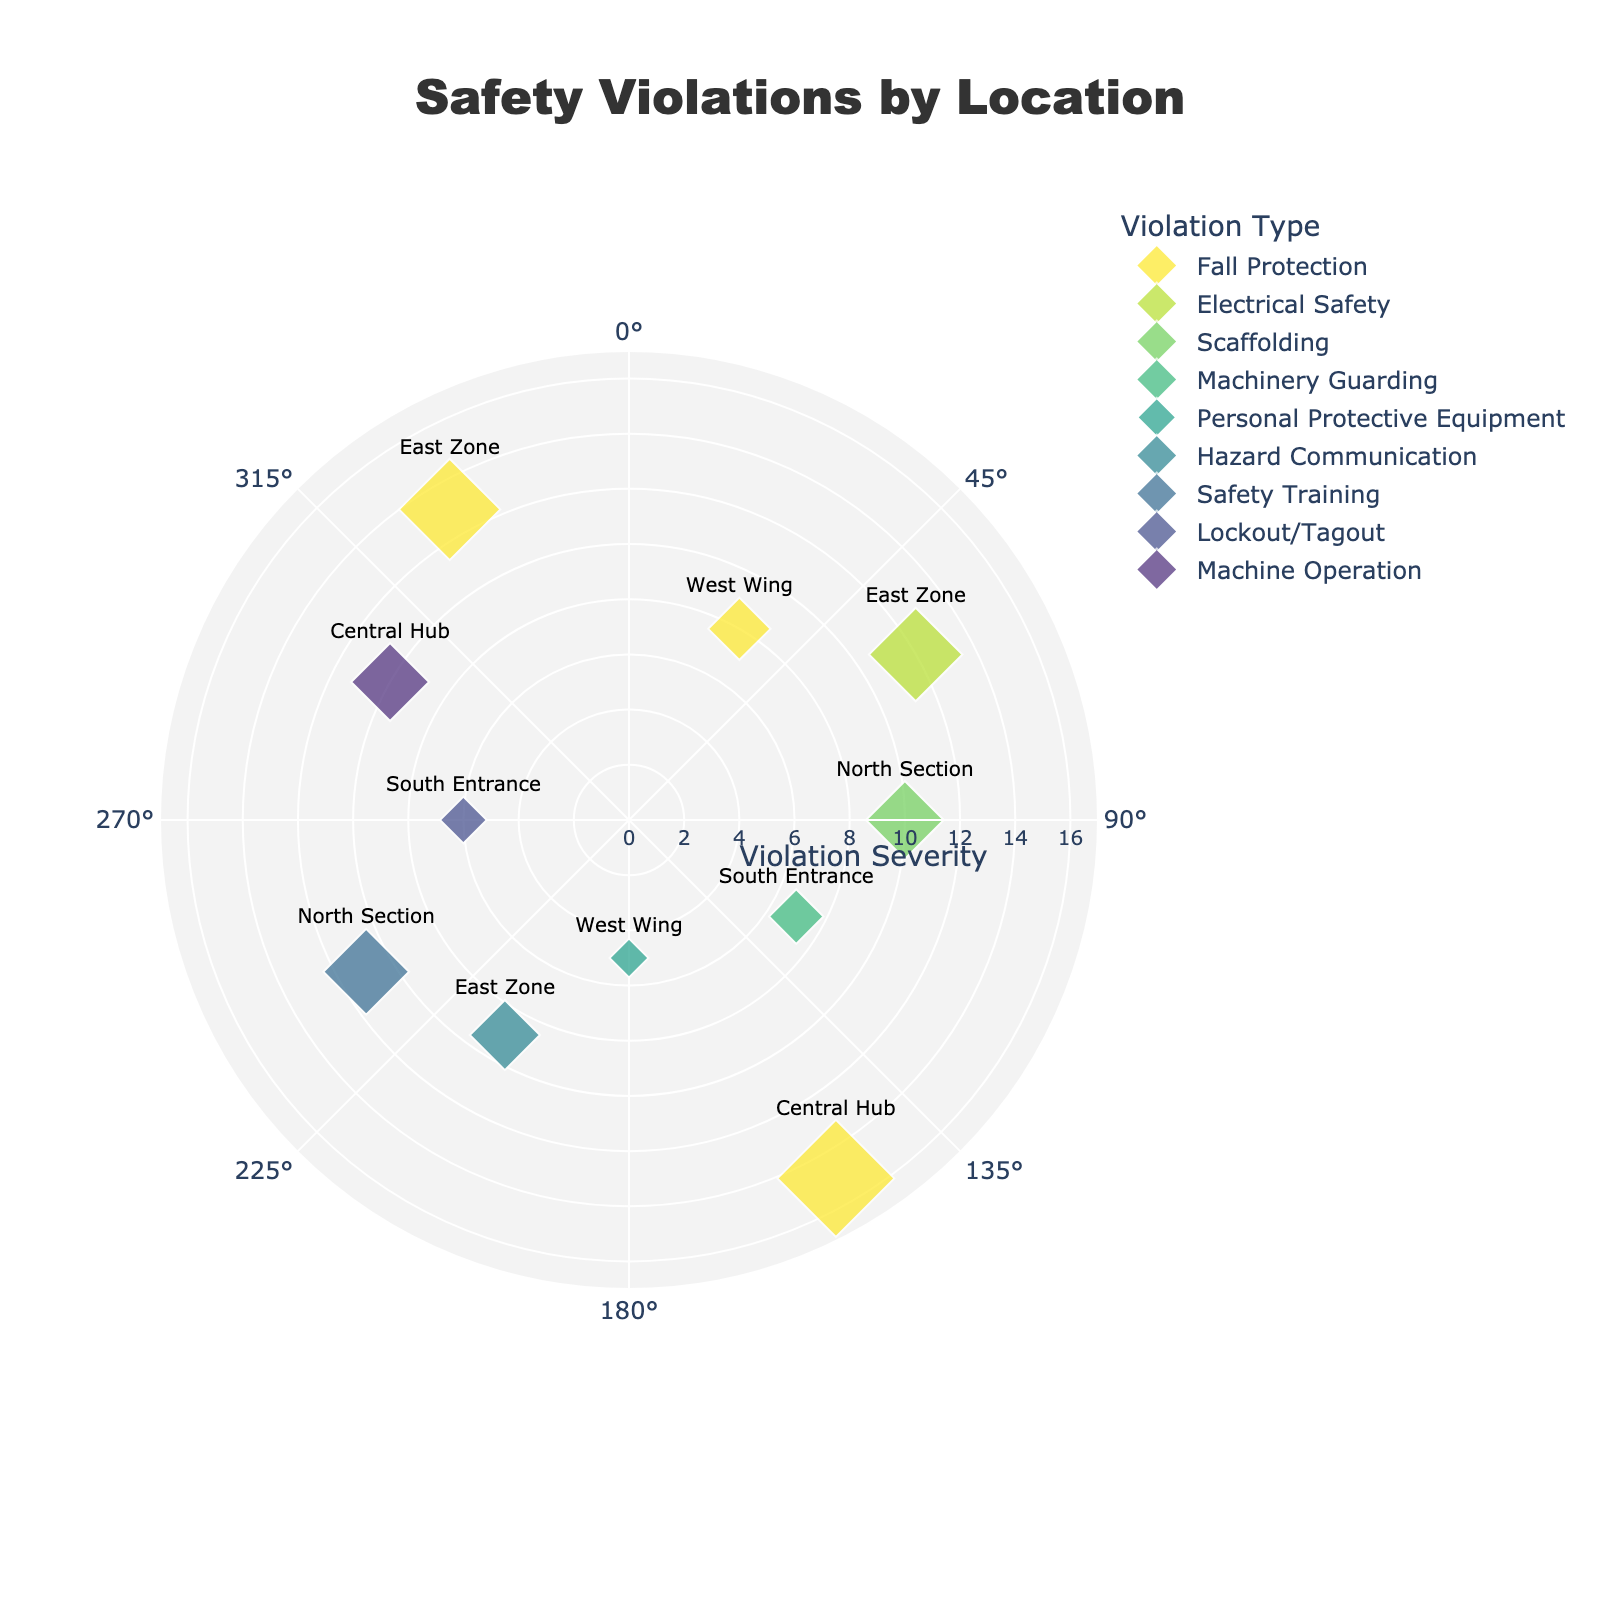What is the title of the chart? The title of the chart is located at the top center of the figure. It is used to describe the main topic or focus of the chart.
Answer: Safety Violations by Location What is the range of violation severity shown in the radial axis? The radial axis displays the range of violation severity. The lowest value starts at 0, and based on the figure, it extends up to the maximum value shown plus some buffer.
Answer: 0 to 17 How many safety violations were detected in the West Wing? From the chart, each location is identified by the text positioned near the data points. Count the number of data points labeled as "West Wing."
Answer: 2 Which violation type has the largest number of detections in a single location? Determine the violation type by comparing the size of data point markers for each type, which is proportional to the number of detections. The largest number corresponds to the "Distance" value of the markers.
Answer: Fall Protection What are the three locations with the highest severity of Fall Protection violations? Identify the data points associated with Fall Protection. Since the severity is denoted by the "Distance" value, find the three highest values and note their corresponding locations.
Answer: Central Hub, East Zone, West Wing How does the severity of violations in the South Entrance compare to those in the Central Hub? Check the distances of the data points for each specific location. Compare the distances (severity levels) of detected violations in the South Entrance with those in the Central Hub.
Answer: Central Hub has higher severity What's the total severity value of all detected violations in the North Section? Sum the "Distance" values of all safety violations detected in the North Section for a total severity measure.
Answer: 21 Which violation type is detected in all four zones? Look at the labels of each violation type and check which of them appear in all zones (West Wing, East Zone, North Section, and South Entrance).
Answer: None What location registered the highest number of types of safety violations? Count the different types of violations detected in each location. The location with the most types has the highest count.
Answer: East Zone Which direction shows the most frequent violations outside the norm (i.e., most spread out from the center)? Review the spread of violations based on their angular location and distance from the center to determine the direction with the most frequent occurrences far from the center.
Answer: East 